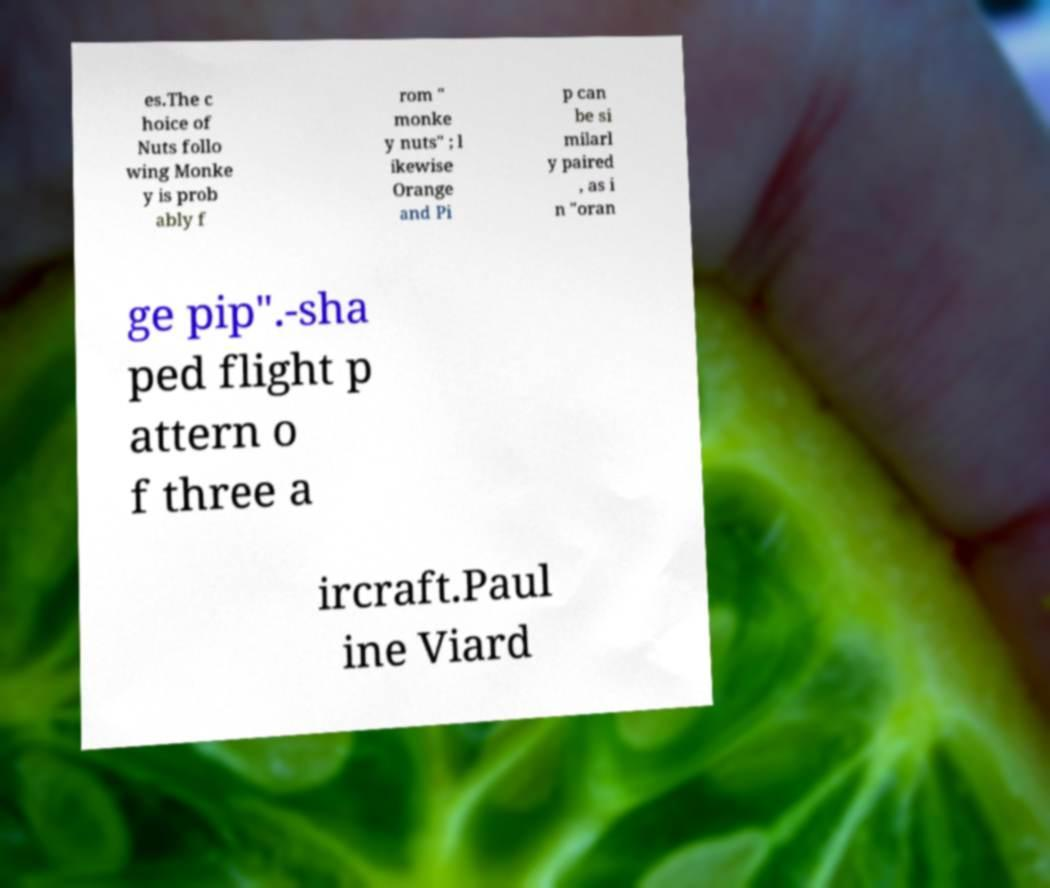What messages or text are displayed in this image? I need them in a readable, typed format. es.The c hoice of Nuts follo wing Monke y is prob ably f rom " monke y nuts" ; l ikewise Orange and Pi p can be si milarl y paired , as i n "oran ge pip".-sha ped flight p attern o f three a ircraft.Paul ine Viard 